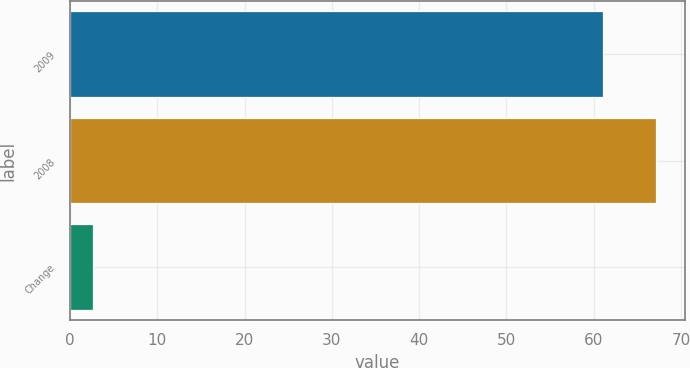Convert chart. <chart><loc_0><loc_0><loc_500><loc_500><bar_chart><fcel>2009<fcel>2008<fcel>Change<nl><fcel>61<fcel>67.1<fcel>2.7<nl></chart> 